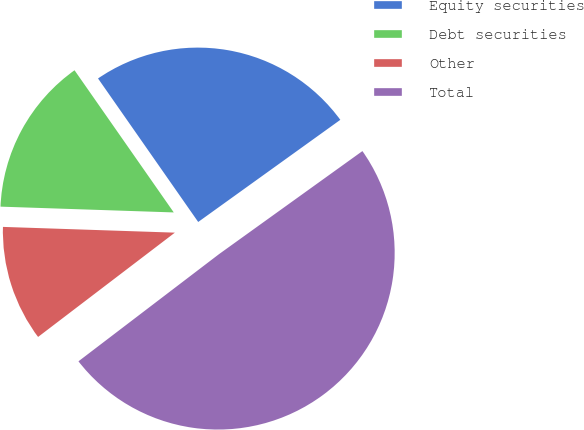Convert chart. <chart><loc_0><loc_0><loc_500><loc_500><pie_chart><fcel>Equity securities<fcel>Debt securities<fcel>Other<fcel>Total<nl><fcel>24.78%<fcel>14.77%<fcel>10.9%<fcel>49.55%<nl></chart> 